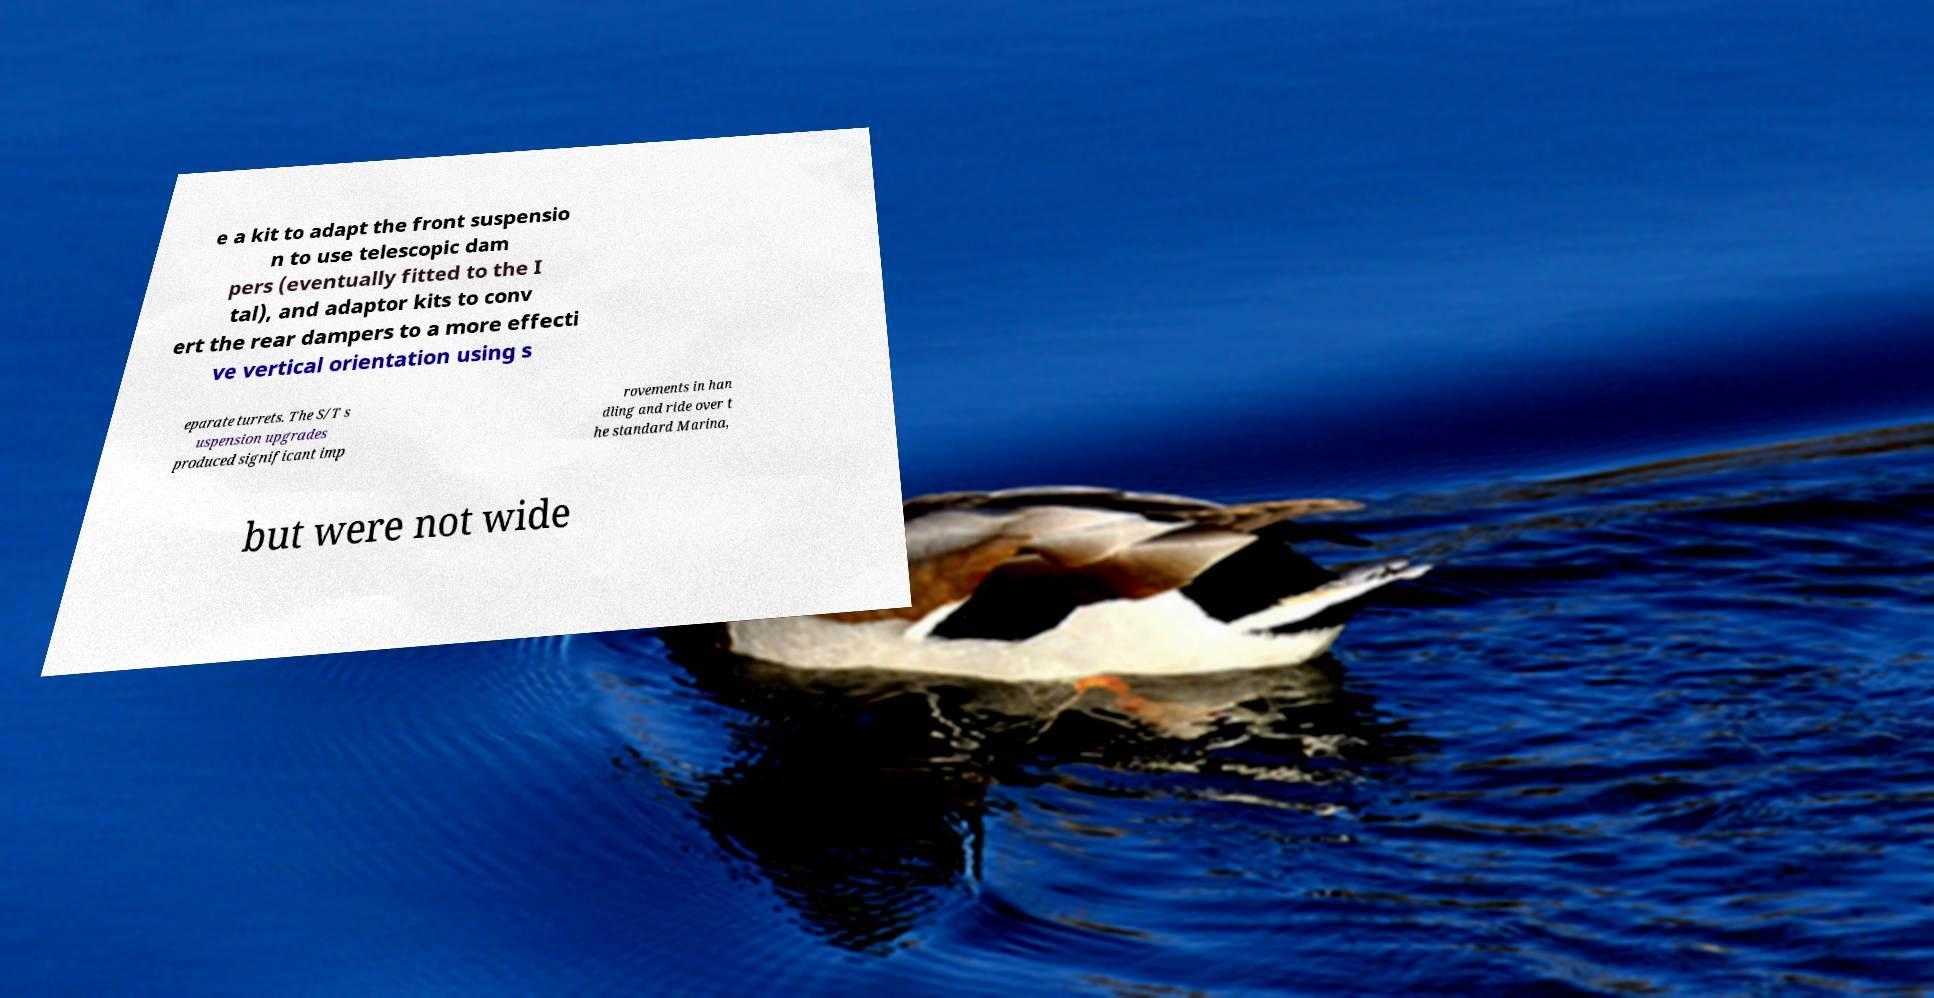Could you extract and type out the text from this image? e a kit to adapt the front suspensio n to use telescopic dam pers (eventually fitted to the I tal), and adaptor kits to conv ert the rear dampers to a more effecti ve vertical orientation using s eparate turrets. The S/T s uspension upgrades produced significant imp rovements in han dling and ride over t he standard Marina, but were not wide 